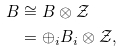<formula> <loc_0><loc_0><loc_500><loc_500>B & \cong B \otimes \mathcal { Z } \\ & = \oplus _ { i } B _ { i } \otimes \mathcal { Z } ,</formula> 